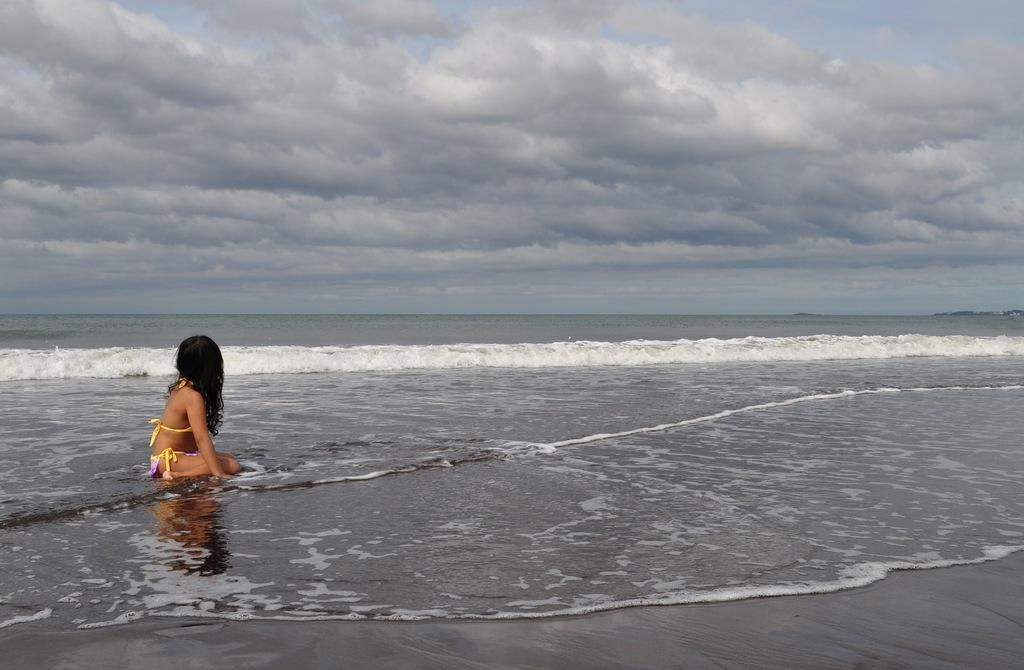Who is the main subject in the image? There is a girl in the image. What is the girl wearing? The girl is wearing a yellow bikini. Where is the girl sitting in the image? The girl is sitting on a beach. What is visible in the sky in the image? There are clouds in the sky. Can you see any branches in the image? There are no branches visible in the image. Are there any chickens present in the image? There are no chickens present in the image. 